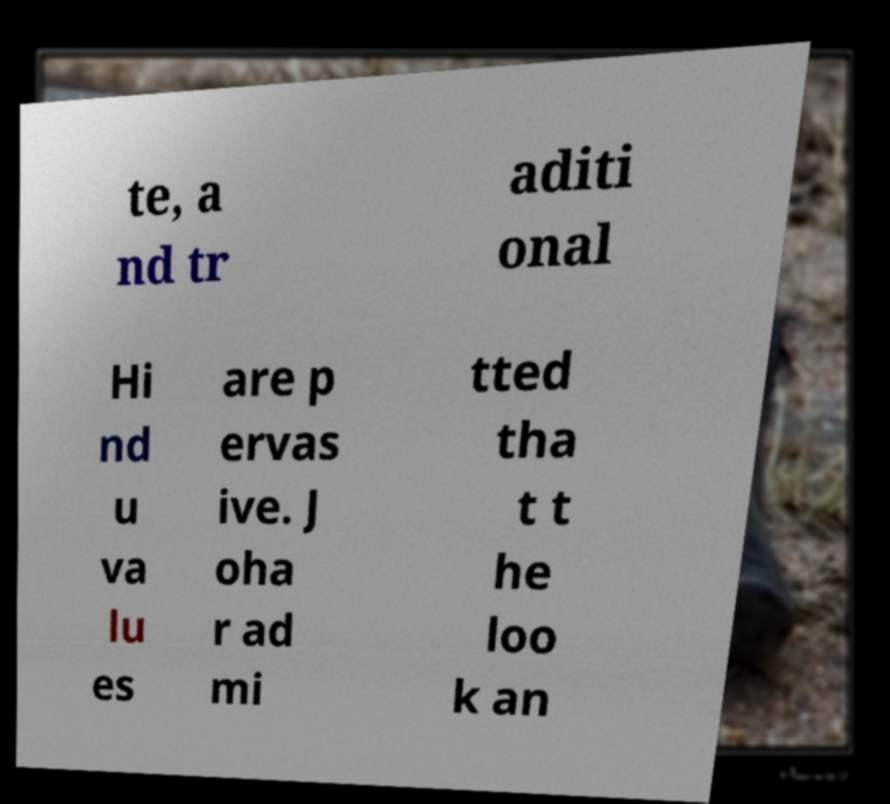I need the written content from this picture converted into text. Can you do that? te, a nd tr aditi onal Hi nd u va lu es are p ervas ive. J oha r ad mi tted tha t t he loo k an 